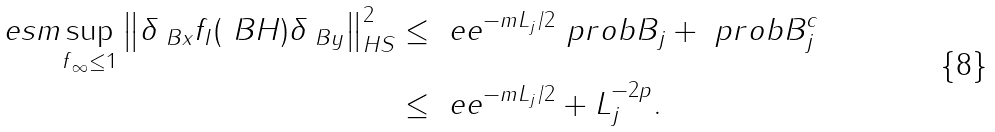<formula> <loc_0><loc_0><loc_500><loc_500>\ e s m { \sup _ { \| f \| _ { \infty } \leq 1 } \left \| \delta _ { \ B x } f _ { I } ( \ B H ) \delta _ { \ B y } \right \| ^ { 2 } _ { H S } } & \leq \ e e ^ { - m L _ { j } / 2 } \ p r o b { B _ { j } } + \ p r o b { B _ { j } ^ { c } } \\ & \leq \ e e ^ { - m L _ { j } / 2 } + L _ { j } ^ { - 2 p } .</formula> 